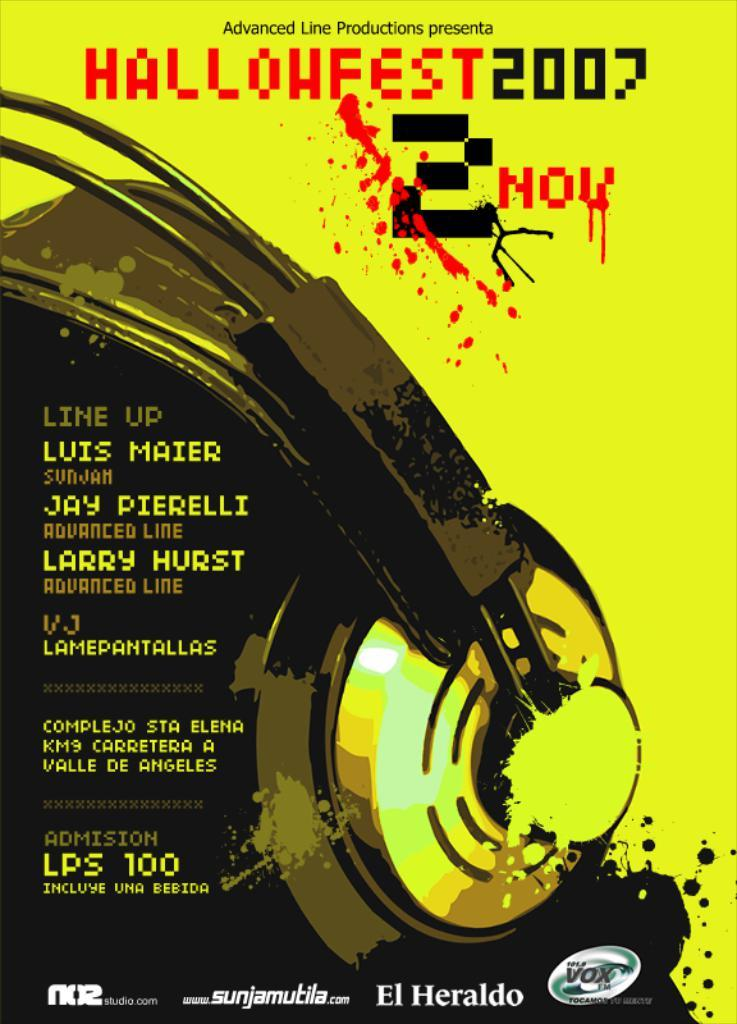<image>
Render a clear and concise summary of the photo. A poster for a Haloween event occuring in 2007. 